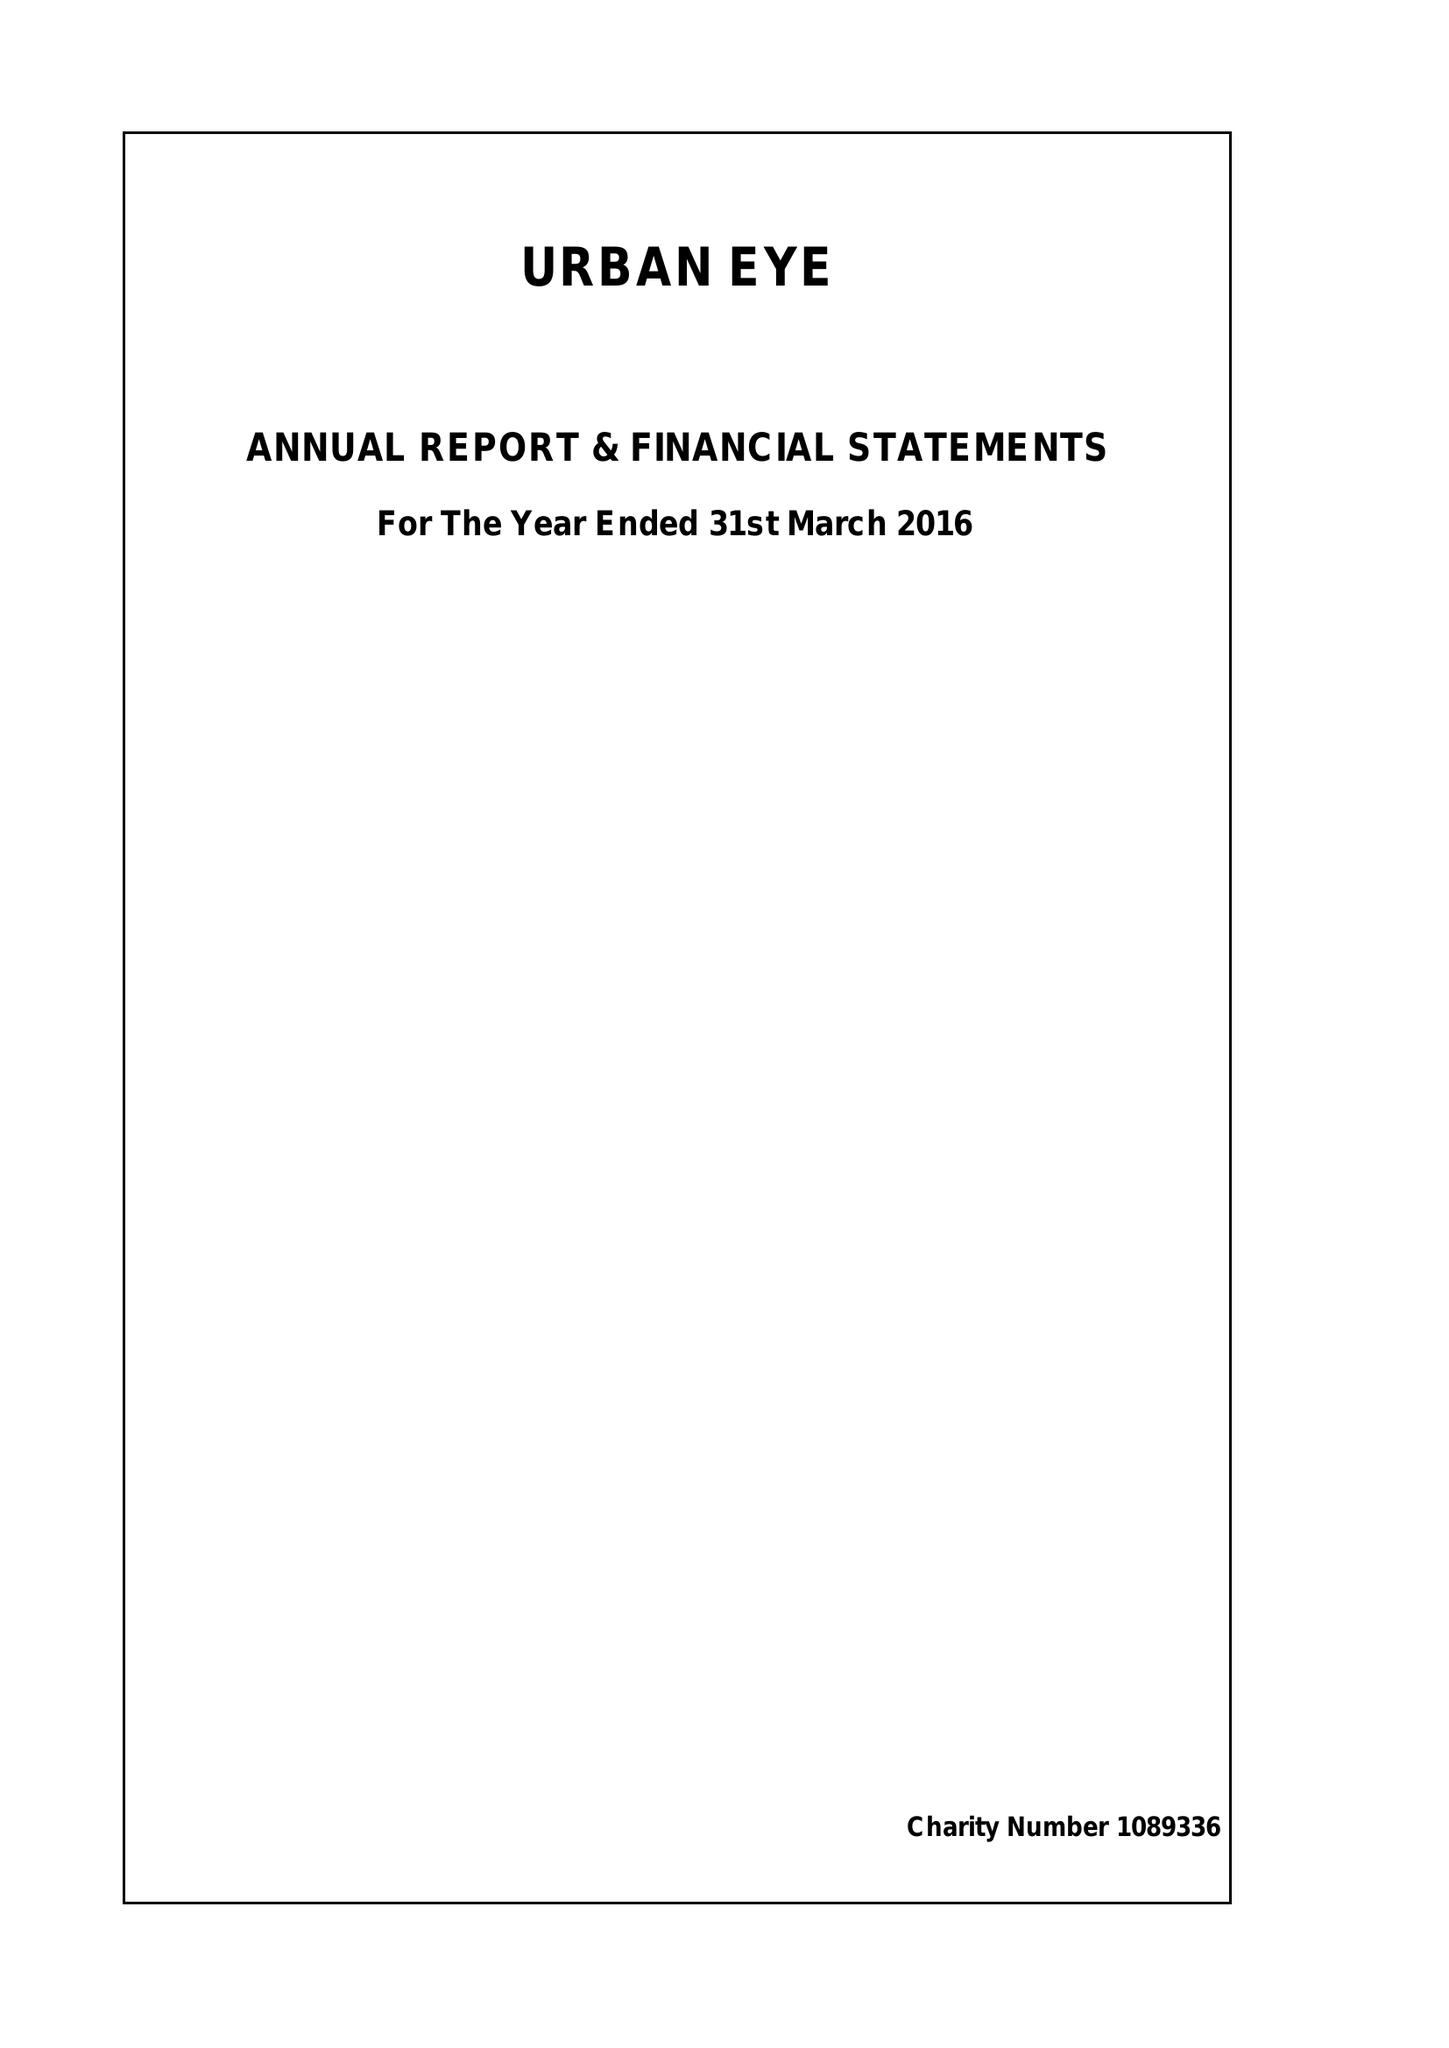What is the value for the address__postcode?
Answer the question using a single word or phrase. W11 4AT 